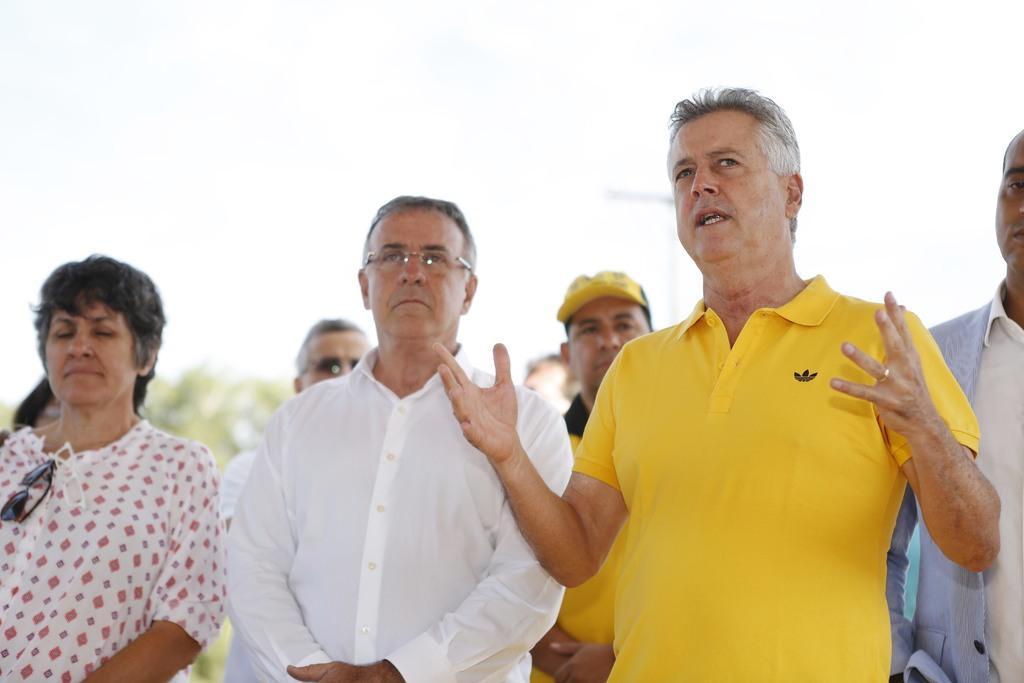Please provide a concise description of this image. In this image, we can see a group of people are standing. On the right side of the image, we can see a person is talking. Background we can see trees and sky. 